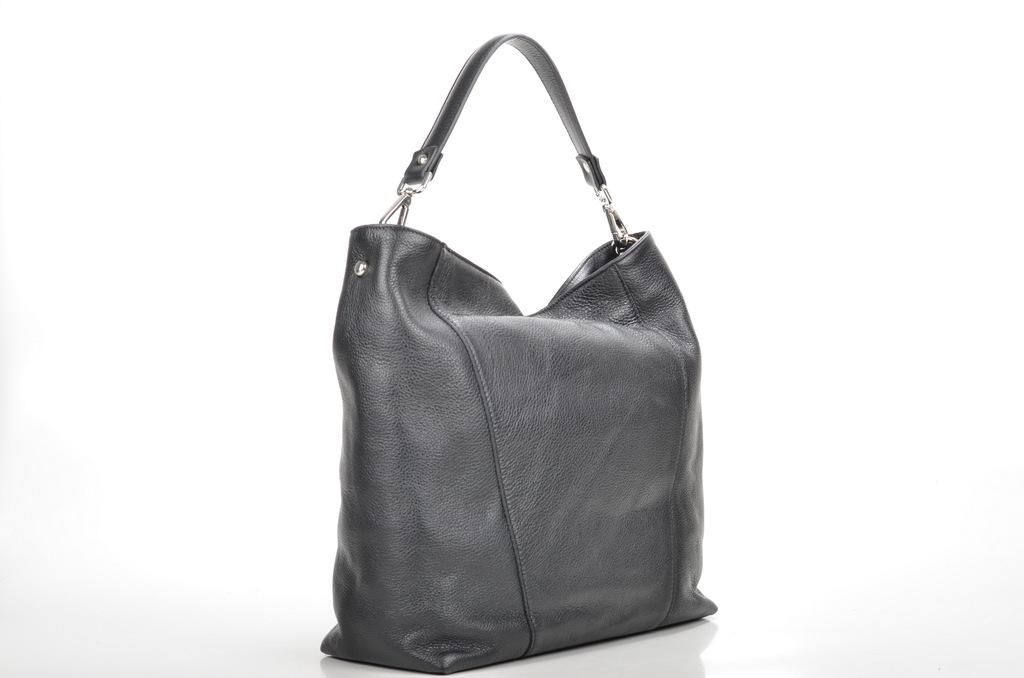What object can be seen in the image? There is a bag in the image. What type of hammer is being used to cut the roll in the image? There is no hammer, roll, or cutting activity present in the image; it only features a bag. 